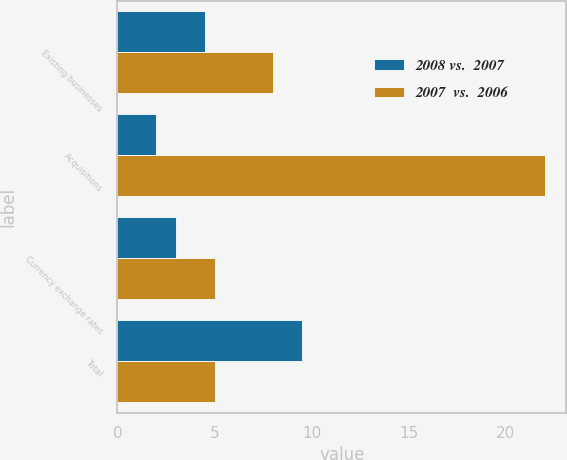Convert chart. <chart><loc_0><loc_0><loc_500><loc_500><stacked_bar_chart><ecel><fcel>Existing businesses<fcel>Acquisitions<fcel>Currency exchange rates<fcel>Total<nl><fcel>2008 vs.  2007<fcel>4.5<fcel>2<fcel>3<fcel>9.5<nl><fcel>2007  vs.  2006<fcel>8<fcel>22<fcel>5<fcel>5<nl></chart> 